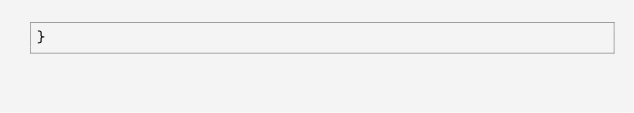Convert code to text. <code><loc_0><loc_0><loc_500><loc_500><_CSS_>}</code> 